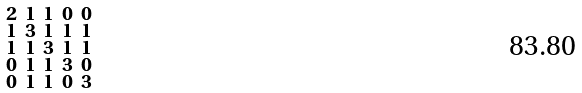Convert formula to latex. <formula><loc_0><loc_0><loc_500><loc_500>\begin{smallmatrix} 2 & 1 & 1 & 0 & 0 \\ 1 & 3 & 1 & 1 & 1 \\ 1 & 1 & 3 & 1 & 1 \\ 0 & 1 & 1 & 3 & 0 \\ 0 & 1 & 1 & 0 & 3 \end{smallmatrix}</formula> 